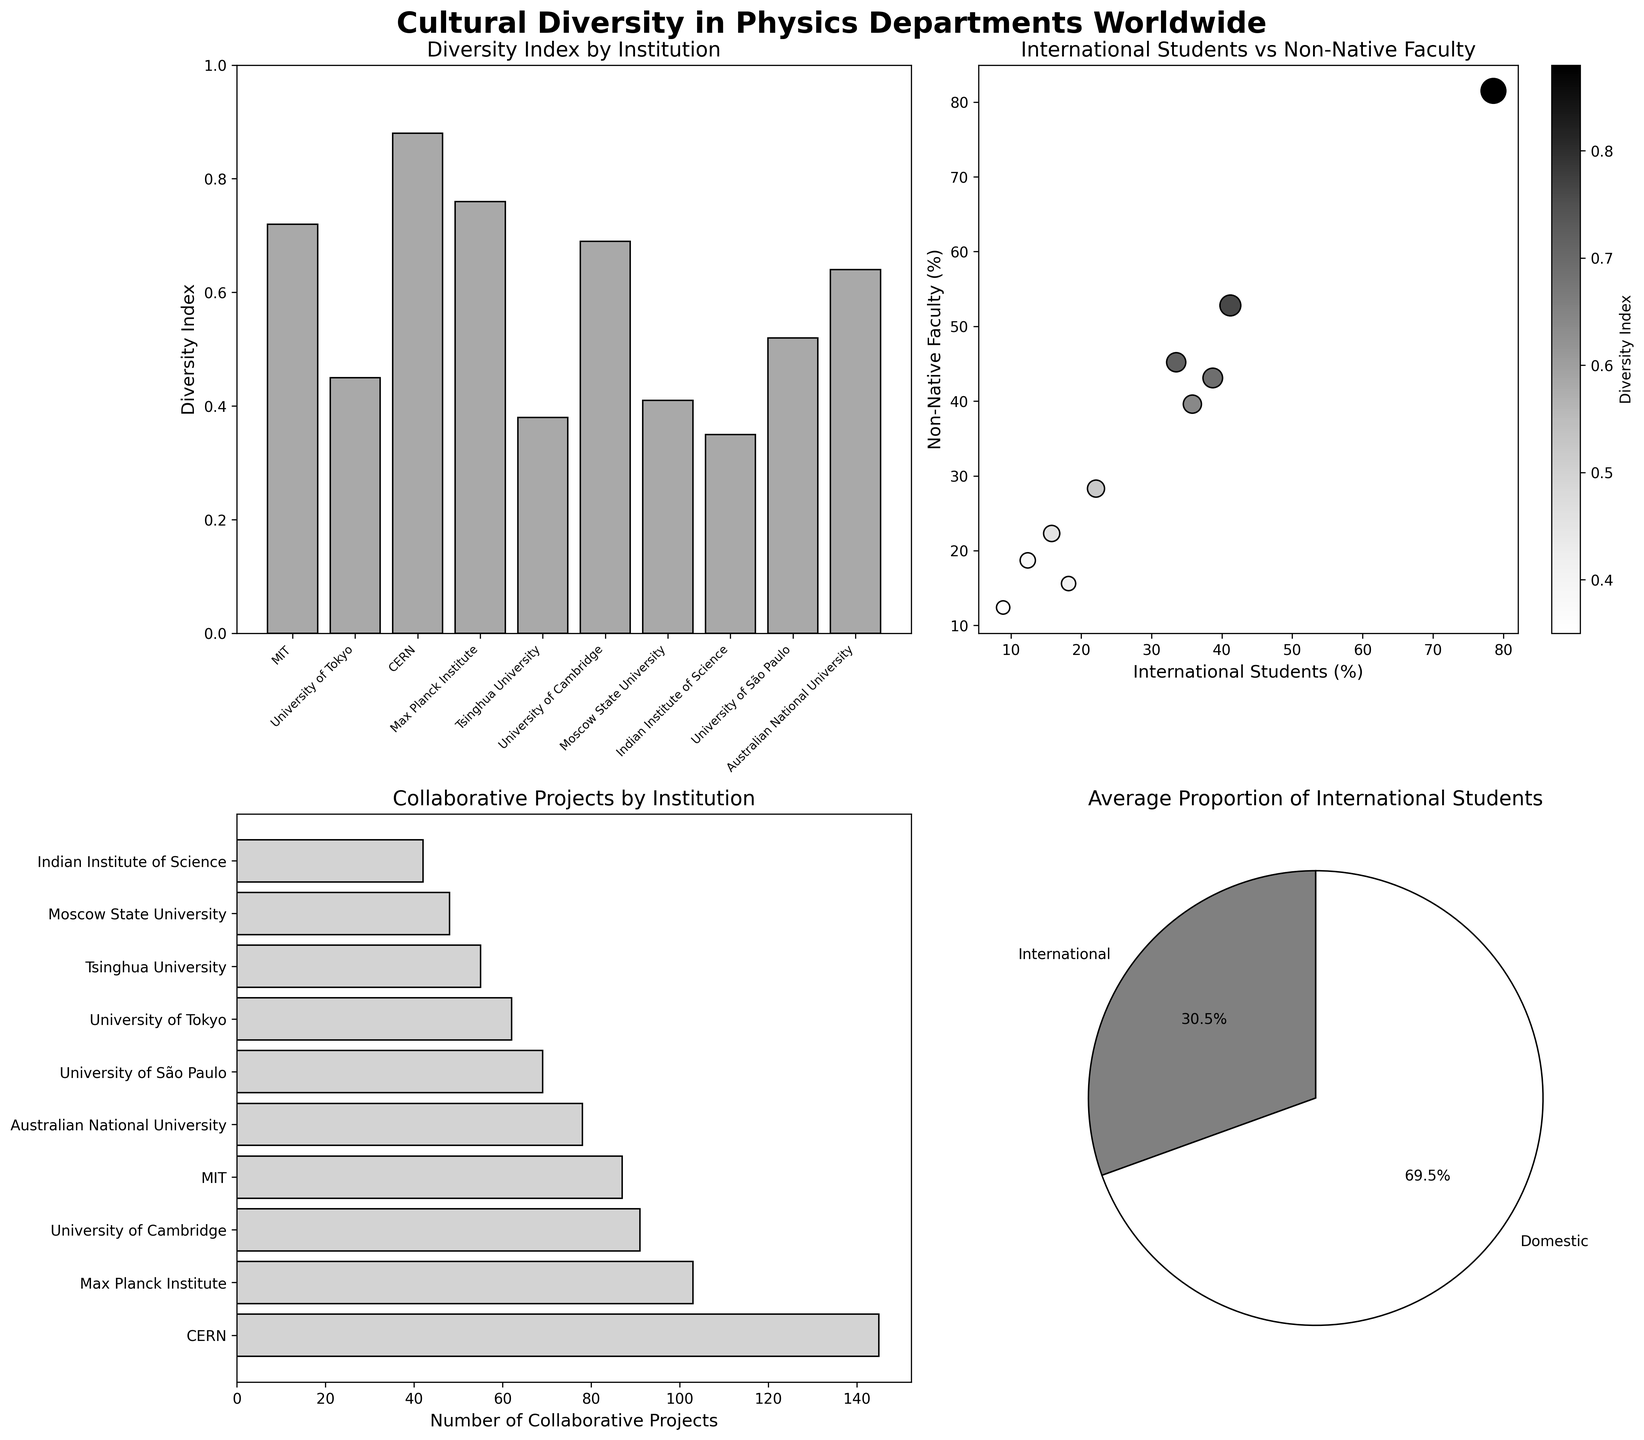What is the range of Diversity Indices across the institutions? By examining the bar plot in the top-left corner, we can identify the minimum and maximum Diversity Indices. The minimum is for the Indian Institute of Science (0.35) and the maximum is for CERN (0.88). Therefore, the range is 0.88 - 0.35.
Answer: 0.53 Which institution has the highest number of collaborative projects? By looking at the horizontal bar plot in the bottom-left corner, we see that CERN has the highest number of collaborative projects with a value of 145.
Answer: CERN What is the sum of International Students' Percentage for MIT and University of Cambridge? From the dataset on the scatter plot and pie chart, we locate the percentages: MIT (33.5) and University of Cambridge (38.7). Summing these values gives us 33.5 + 38.7.
Answer: 72.2 Which institution appears to have the closest International Students and Non-Native Faculty percentages? From the scatter plot in the top-right, Australian National University has close values for International Students (35.8%) and Non-Native Faculty (39.6%).
Answer: Australian National University How many institutions have a Diversity Index greater than 0.5? By examining the bar plot in the top-left, institutions with a Diversity Index greater than 0.5 are: MIT, CERN, Max Planck Institute, University of Cambridge, University of São Paulo, and Australian National University. Counting these, we get 6.
Answer: 6 What is the proportion of domestic students? From the pie chart in the bottom-right, it shows that International Students make up the proportion indicated. By calculating from the pie chart: 100% - International Students (an average of the percentages of all institutions, appearing to be around 29.1%) gives us 100% - 29.1%.
Answer: 70.9% Which institution has the closest balance in collaborative projects and Diversity Index? By comparing the horizontal bar plot (collaborative projects) and the bar plot (Diversity Index), the University of Cambridge has close quantities with 91 collaborative projects and a Diversity Index of 0.69, showing a reasonable balance.
Answer: University of Cambridge Which institutions have more International Students than Non-Native Faculty members? Looking at the scatter plot, institutions with higher International Students percentages than Non-Native Faculty are: CERN and MIT, as their corresponding points on the scatter plot lie above the diagonal (45-degree line) where these percentages would be equal.
Answer: CERN and MIT 